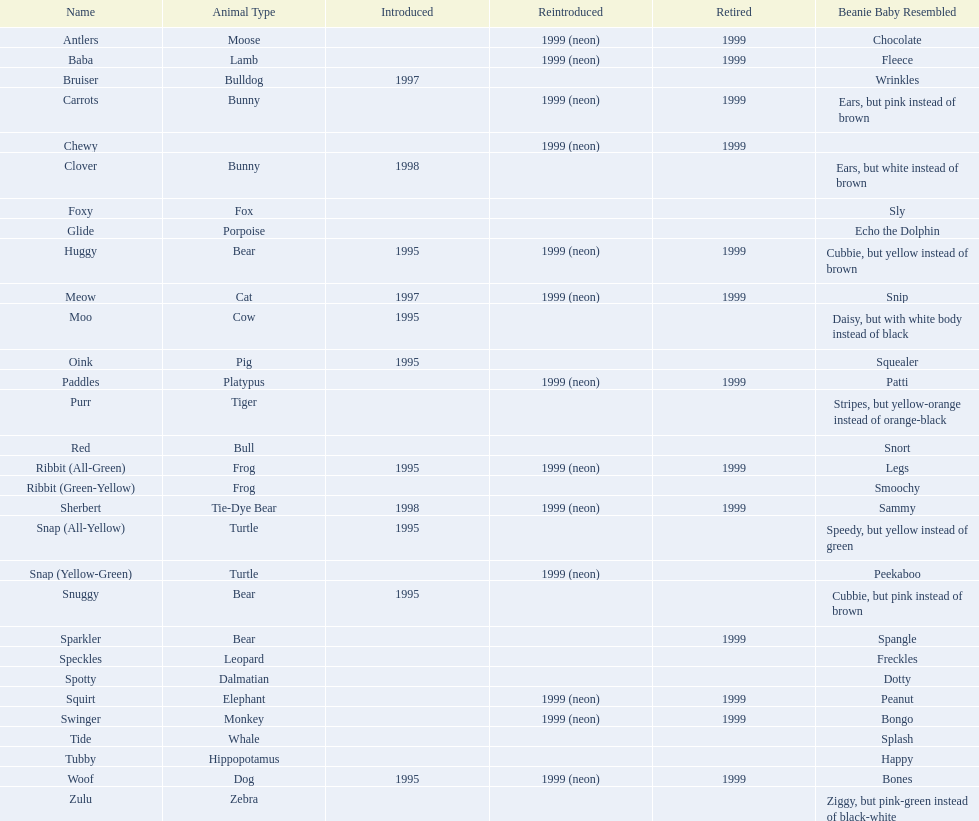Which of the specified pillow pals have incomplete data in three or more sections? Chewy, Foxy, Glide, Purr, Red, Ribbit (Green-Yellow), Speckles, Spotty, Tide, Tubby, Zulu. From those, which one has insufficient information in the animal kind category? Chewy. Would you mind parsing the complete table? {'header': ['Name', 'Animal Type', 'Introduced', 'Reintroduced', 'Retired', 'Beanie Baby Resembled'], 'rows': [['Antlers', 'Moose', '', '1999 (neon)', '1999', 'Chocolate'], ['Baba', 'Lamb', '', '1999 (neon)', '1999', 'Fleece'], ['Bruiser', 'Bulldog', '1997', '', '', 'Wrinkles'], ['Carrots', 'Bunny', '', '1999 (neon)', '1999', 'Ears, but pink instead of brown'], ['Chewy', '', '', '1999 (neon)', '1999', ''], ['Clover', 'Bunny', '1998', '', '', 'Ears, but white instead of brown'], ['Foxy', 'Fox', '', '', '', 'Sly'], ['Glide', 'Porpoise', '', '', '', 'Echo the Dolphin'], ['Huggy', 'Bear', '1995', '1999 (neon)', '1999', 'Cubbie, but yellow instead of brown'], ['Meow', 'Cat', '1997', '1999 (neon)', '1999', 'Snip'], ['Moo', 'Cow', '1995', '', '', 'Daisy, but with white body instead of black'], ['Oink', 'Pig', '1995', '', '', 'Squealer'], ['Paddles', 'Platypus', '', '1999 (neon)', '1999', 'Patti'], ['Purr', 'Tiger', '', '', '', 'Stripes, but yellow-orange instead of orange-black'], ['Red', 'Bull', '', '', '', 'Snort'], ['Ribbit (All-Green)', 'Frog', '1995', '1999 (neon)', '1999', 'Legs'], ['Ribbit (Green-Yellow)', 'Frog', '', '', '', 'Smoochy'], ['Sherbert', 'Tie-Dye Bear', '1998', '1999 (neon)', '1999', 'Sammy'], ['Snap (All-Yellow)', 'Turtle', '1995', '', '', 'Speedy, but yellow instead of green'], ['Snap (Yellow-Green)', 'Turtle', '', '1999 (neon)', '', 'Peekaboo'], ['Snuggy', 'Bear', '1995', '', '', 'Cubbie, but pink instead of brown'], ['Sparkler', 'Bear', '', '', '1999', 'Spangle'], ['Speckles', 'Leopard', '', '', '', 'Freckles'], ['Spotty', 'Dalmatian', '', '', '', 'Dotty'], ['Squirt', 'Elephant', '', '1999 (neon)', '1999', 'Peanut'], ['Swinger', 'Monkey', '', '1999 (neon)', '1999', 'Bongo'], ['Tide', 'Whale', '', '', '', 'Splash'], ['Tubby', 'Hippopotamus', '', '', '', 'Happy'], ['Woof', 'Dog', '1995', '1999 (neon)', '1999', 'Bones'], ['Zulu', 'Zebra', '', '', '', 'Ziggy, but pink-green instead of black-white']]} 